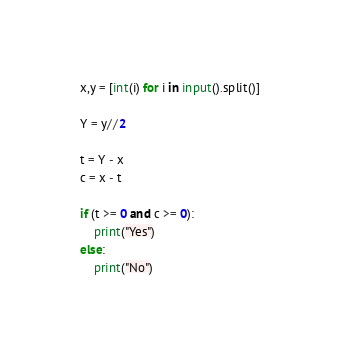<code> <loc_0><loc_0><loc_500><loc_500><_Python_>x,y = [int(i) for i in input().split()]

Y = y//2

t = Y - x
c = x - t

if (t >= 0 and c >= 0):
    print("Yes")
else:
    print("No")</code> 